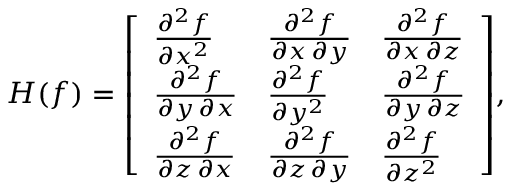Convert formula to latex. <formula><loc_0><loc_0><loc_500><loc_500>H ( f ) = { \left [ \begin{array} { l l l } { { \frac { \partial ^ { 2 } f } { \partial x ^ { 2 } } } } & { { \frac { \partial ^ { 2 } f } { \partial x \, \partial y } } } & { { \frac { \partial ^ { 2 } f } { \partial x \, \partial z } } } \\ { { \frac { \partial ^ { 2 } f } { \partial y \, \partial x } } } & { { \frac { \partial ^ { 2 } f } { \partial y ^ { 2 } } } } & { { \frac { \partial ^ { 2 } f } { \partial y \, \partial z } } } \\ { { \frac { \partial ^ { 2 } f } { \partial z \, \partial x } } } & { { \frac { \partial ^ { 2 } f } { \partial z \, \partial y } } } & { { \frac { \partial ^ { 2 } f } { \partial z ^ { 2 } } } } \end{array} \right ] } ,</formula> 